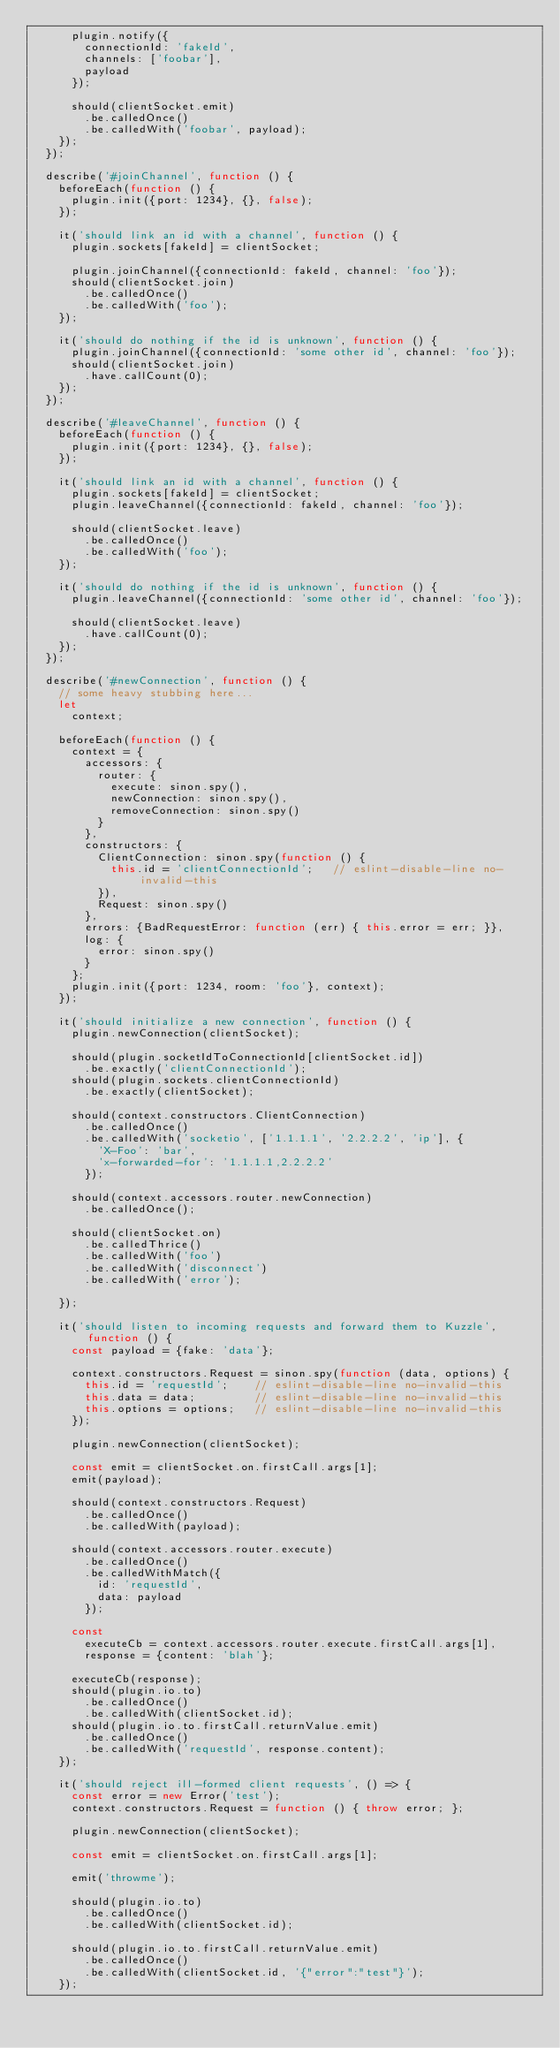Convert code to text. <code><loc_0><loc_0><loc_500><loc_500><_JavaScript_>      plugin.notify({
        connectionId: 'fakeId',
        channels: ['foobar'],
        payload
      });

      should(clientSocket.emit)
        .be.calledOnce()
        .be.calledWith('foobar', payload);
    });
  });

  describe('#joinChannel', function () {
    beforeEach(function () {
      plugin.init({port: 1234}, {}, false);
    });

    it('should link an id with a channel', function () {
      plugin.sockets[fakeId] = clientSocket;

      plugin.joinChannel({connectionId: fakeId, channel: 'foo'});
      should(clientSocket.join)
        .be.calledOnce()
        .be.calledWith('foo');
    });

    it('should do nothing if the id is unknown', function () {
      plugin.joinChannel({connectionId: 'some other id', channel: 'foo'});
      should(clientSocket.join)
        .have.callCount(0);
    });
  });

  describe('#leaveChannel', function () {
    beforeEach(function () {
      plugin.init({port: 1234}, {}, false);
    });

    it('should link an id with a channel', function () {
      plugin.sockets[fakeId] = clientSocket;
      plugin.leaveChannel({connectionId: fakeId, channel: 'foo'});

      should(clientSocket.leave)
        .be.calledOnce()
        .be.calledWith('foo');
    });

    it('should do nothing if the id is unknown', function () {
      plugin.leaveChannel({connectionId: 'some other id', channel: 'foo'});

      should(clientSocket.leave)
        .have.callCount(0);
    });
  });

  describe('#newConnection', function () {
    // some heavy stubbing here...
    let
      context;

    beforeEach(function () {
      context = {
        accessors: {
          router: {
            execute: sinon.spy(),
            newConnection: sinon.spy(),
            removeConnection: sinon.spy()
          }
        },
        constructors: {
          ClientConnection: sinon.spy(function () {
            this.id = 'clientConnectionId';   // eslint-disable-line no-invalid-this
          }),
          Request: sinon.spy()
        },
        errors: {BadRequestError: function (err) { this.error = err; }},
        log: {
          error: sinon.spy()
        }
      };
      plugin.init({port: 1234, room: 'foo'}, context);
    });

    it('should initialize a new connection', function () {
      plugin.newConnection(clientSocket);

      should(plugin.socketIdToConnectionId[clientSocket.id])
        .be.exactly('clientConnectionId');
      should(plugin.sockets.clientConnectionId)
        .be.exactly(clientSocket);

      should(context.constructors.ClientConnection)
        .be.calledOnce()
        .be.calledWith('socketio', ['1.1.1.1', '2.2.2.2', 'ip'], {
          'X-Foo': 'bar',
          'x-forwarded-for': '1.1.1.1,2.2.2.2'
        });

      should(context.accessors.router.newConnection)
        .be.calledOnce();

      should(clientSocket.on)
        .be.calledThrice()
        .be.calledWith('foo')
        .be.calledWith('disconnect')
        .be.calledWith('error');

    });

    it('should listen to incoming requests and forward them to Kuzzle', function () {
      const payload = {fake: 'data'};

      context.constructors.Request = sinon.spy(function (data, options) {
        this.id = 'requestId';    // eslint-disable-line no-invalid-this
        this.data = data;         // eslint-disable-line no-invalid-this
        this.options = options;   // eslint-disable-line no-invalid-this
      });

      plugin.newConnection(clientSocket);

      const emit = clientSocket.on.firstCall.args[1];
      emit(payload);

      should(context.constructors.Request)
        .be.calledOnce()
        .be.calledWith(payload);

      should(context.accessors.router.execute)
        .be.calledOnce()
        .be.calledWithMatch({
          id: 'requestId',
          data: payload
        });

      const
        executeCb = context.accessors.router.execute.firstCall.args[1],
        response = {content: 'blah'};

      executeCb(response);
      should(plugin.io.to)
        .be.calledOnce()
        .be.calledWith(clientSocket.id);
      should(plugin.io.to.firstCall.returnValue.emit)
        .be.calledOnce()
        .be.calledWith('requestId', response.content);
    });

    it('should reject ill-formed client requests', () => {
      const error = new Error('test');
      context.constructors.Request = function () { throw error; };

      plugin.newConnection(clientSocket);

      const emit = clientSocket.on.firstCall.args[1];

      emit('throwme');

      should(plugin.io.to)
        .be.calledOnce()
        .be.calledWith(clientSocket.id);

      should(plugin.io.to.firstCall.returnValue.emit)
        .be.calledOnce()
        .be.calledWith(clientSocket.id, '{"error":"test"}');
    });
</code> 